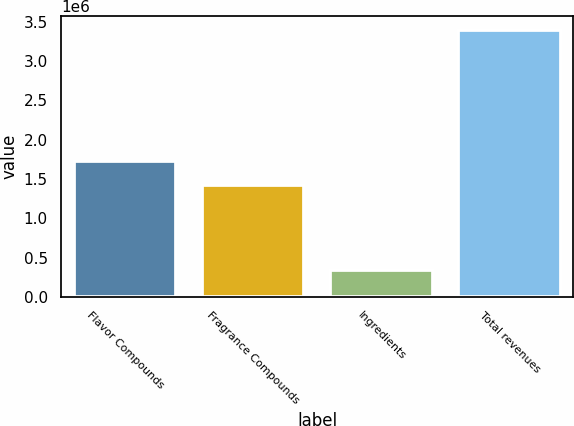Convert chart. <chart><loc_0><loc_0><loc_500><loc_500><bar_chart><fcel>Flavor Compounds<fcel>Fragrance Compounds<fcel>Ingredients<fcel>Total revenues<nl><fcel>1.73029e+06<fcel>1.42461e+06<fcel>341941<fcel>3.39872e+06<nl></chart> 